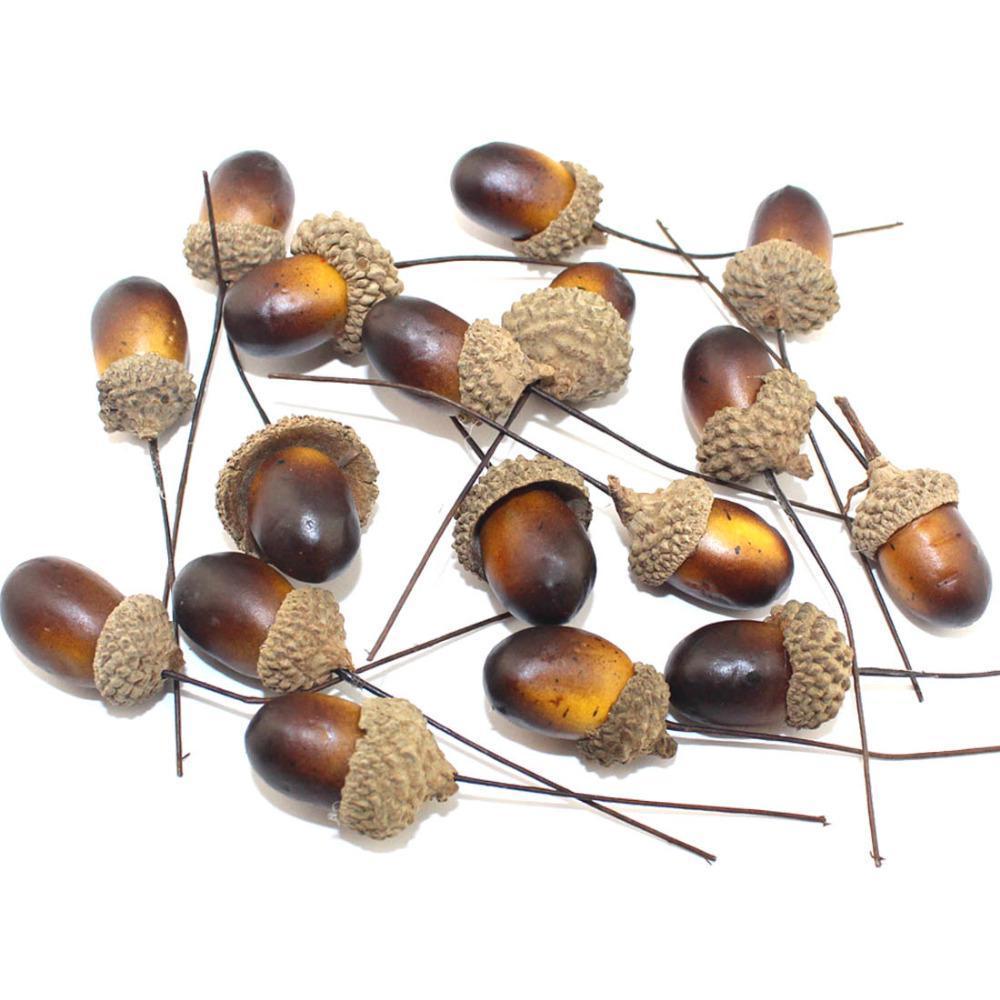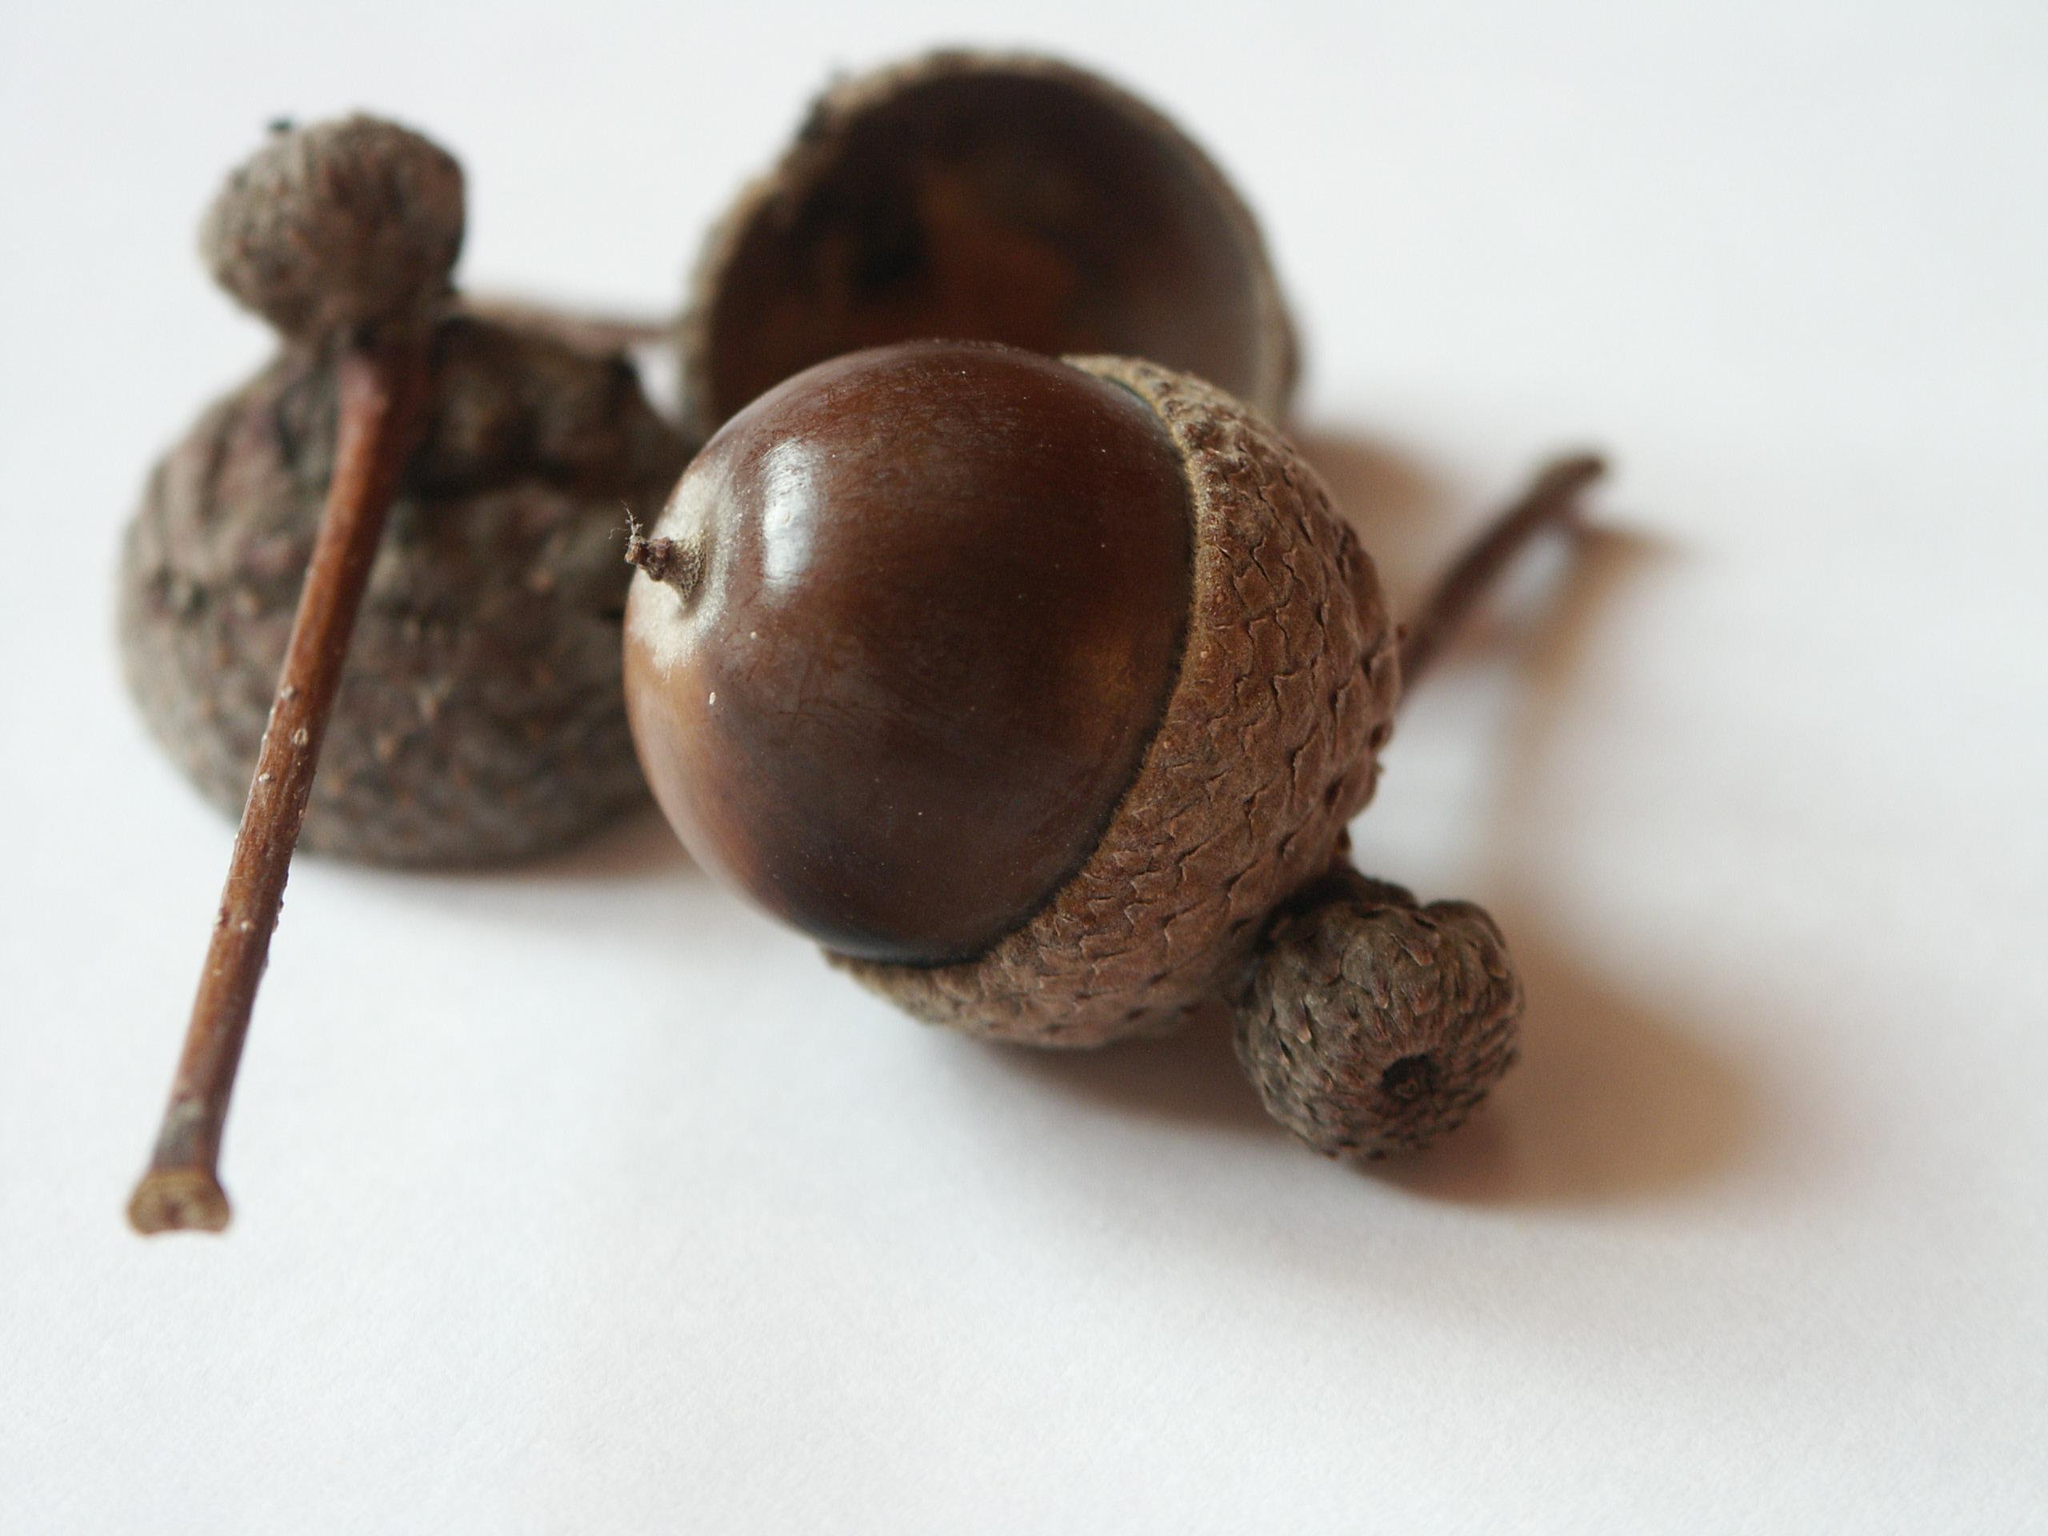The first image is the image on the left, the second image is the image on the right. Analyze the images presented: Is the assertion "One picture shows at least three acorns next to each other." valid? Answer yes or no. Yes. The first image is the image on the left, the second image is the image on the right. For the images displayed, is the sentence "There are more items in the right image than in the left image." factually correct? Answer yes or no. No. 